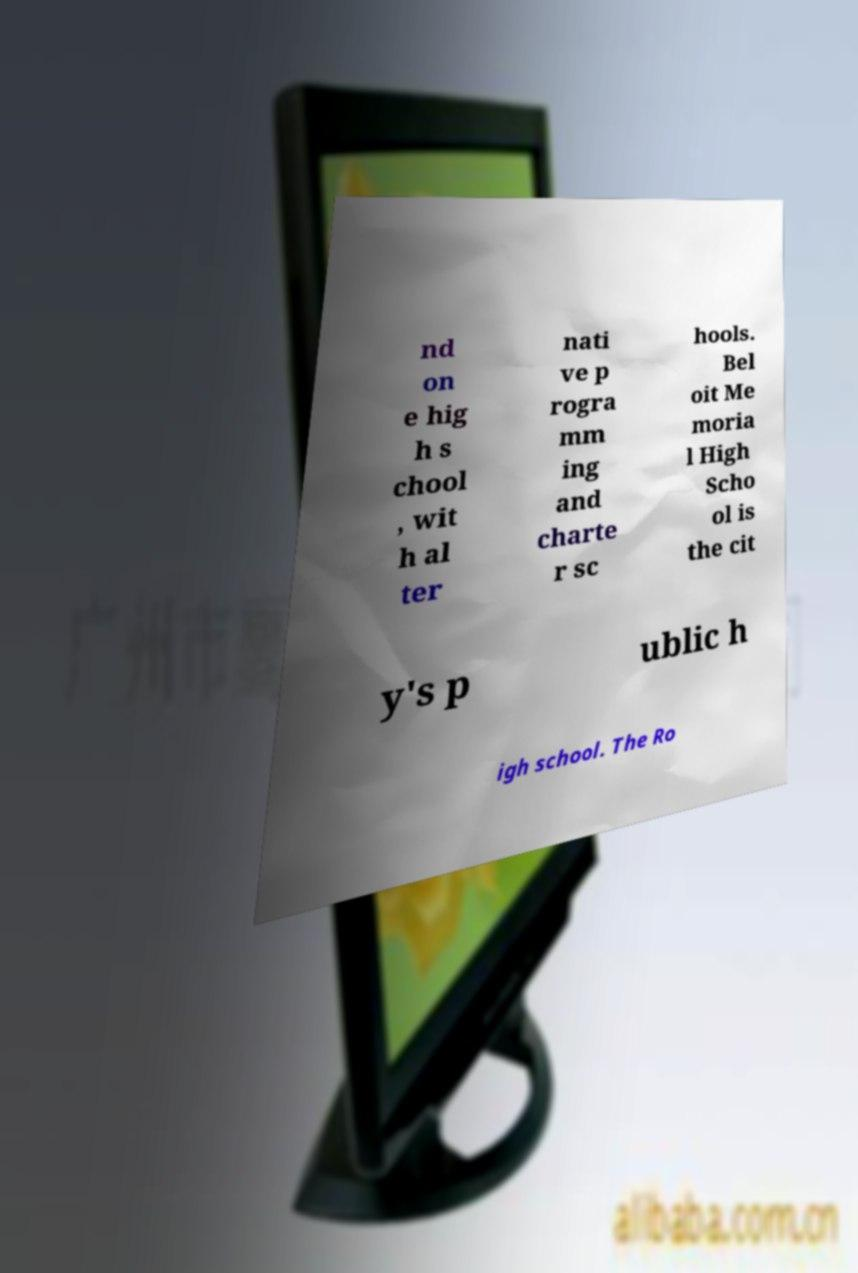What messages or text are displayed in this image? I need them in a readable, typed format. nd on e hig h s chool , wit h al ter nati ve p rogra mm ing and charte r sc hools. Bel oit Me moria l High Scho ol is the cit y's p ublic h igh school. The Ro 